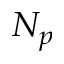<formula> <loc_0><loc_0><loc_500><loc_500>N _ { p }</formula> 